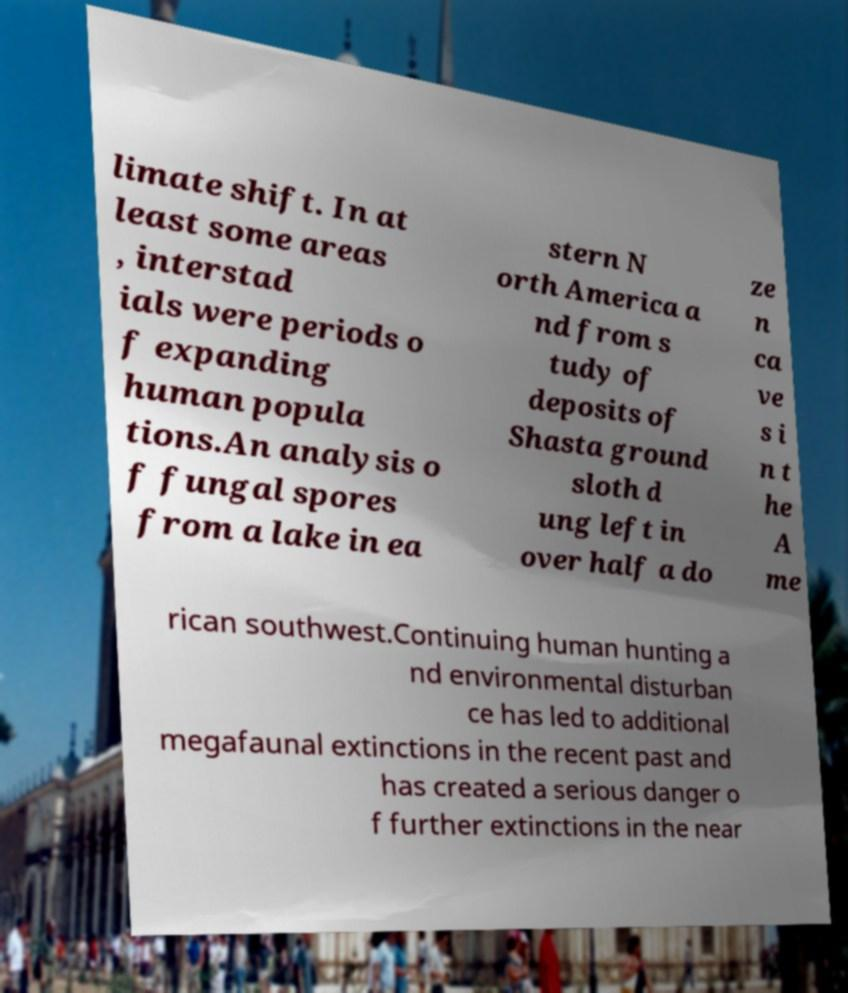Can you accurately transcribe the text from the provided image for me? limate shift. In at least some areas , interstad ials were periods o f expanding human popula tions.An analysis o f fungal spores from a lake in ea stern N orth America a nd from s tudy of deposits of Shasta ground sloth d ung left in over half a do ze n ca ve s i n t he A me rican southwest.Continuing human hunting a nd environmental disturban ce has led to additional megafaunal extinctions in the recent past and has created a serious danger o f further extinctions in the near 